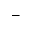Convert formula to latex. <formula><loc_0><loc_0><loc_500><loc_500>-</formula> 